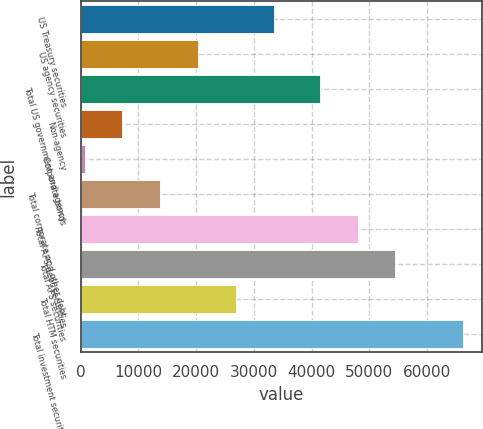Convert chart to OTSL. <chart><loc_0><loc_0><loc_500><loc_500><bar_chart><fcel>US Treasury securities<fcel>US agency securities<fcel>Total US government and agency<fcel>Non-agency<fcel>Corporate bonds<fcel>Total corporate and other debt<fcel>Total AFS debt securities<fcel>Total AFS securities<fcel>Total HTM securities<fcel>Total investment securities<nl><fcel>33490<fcel>20376<fcel>41414<fcel>7262<fcel>705<fcel>13819<fcel>47971<fcel>54528<fcel>26933<fcel>66275<nl></chart> 